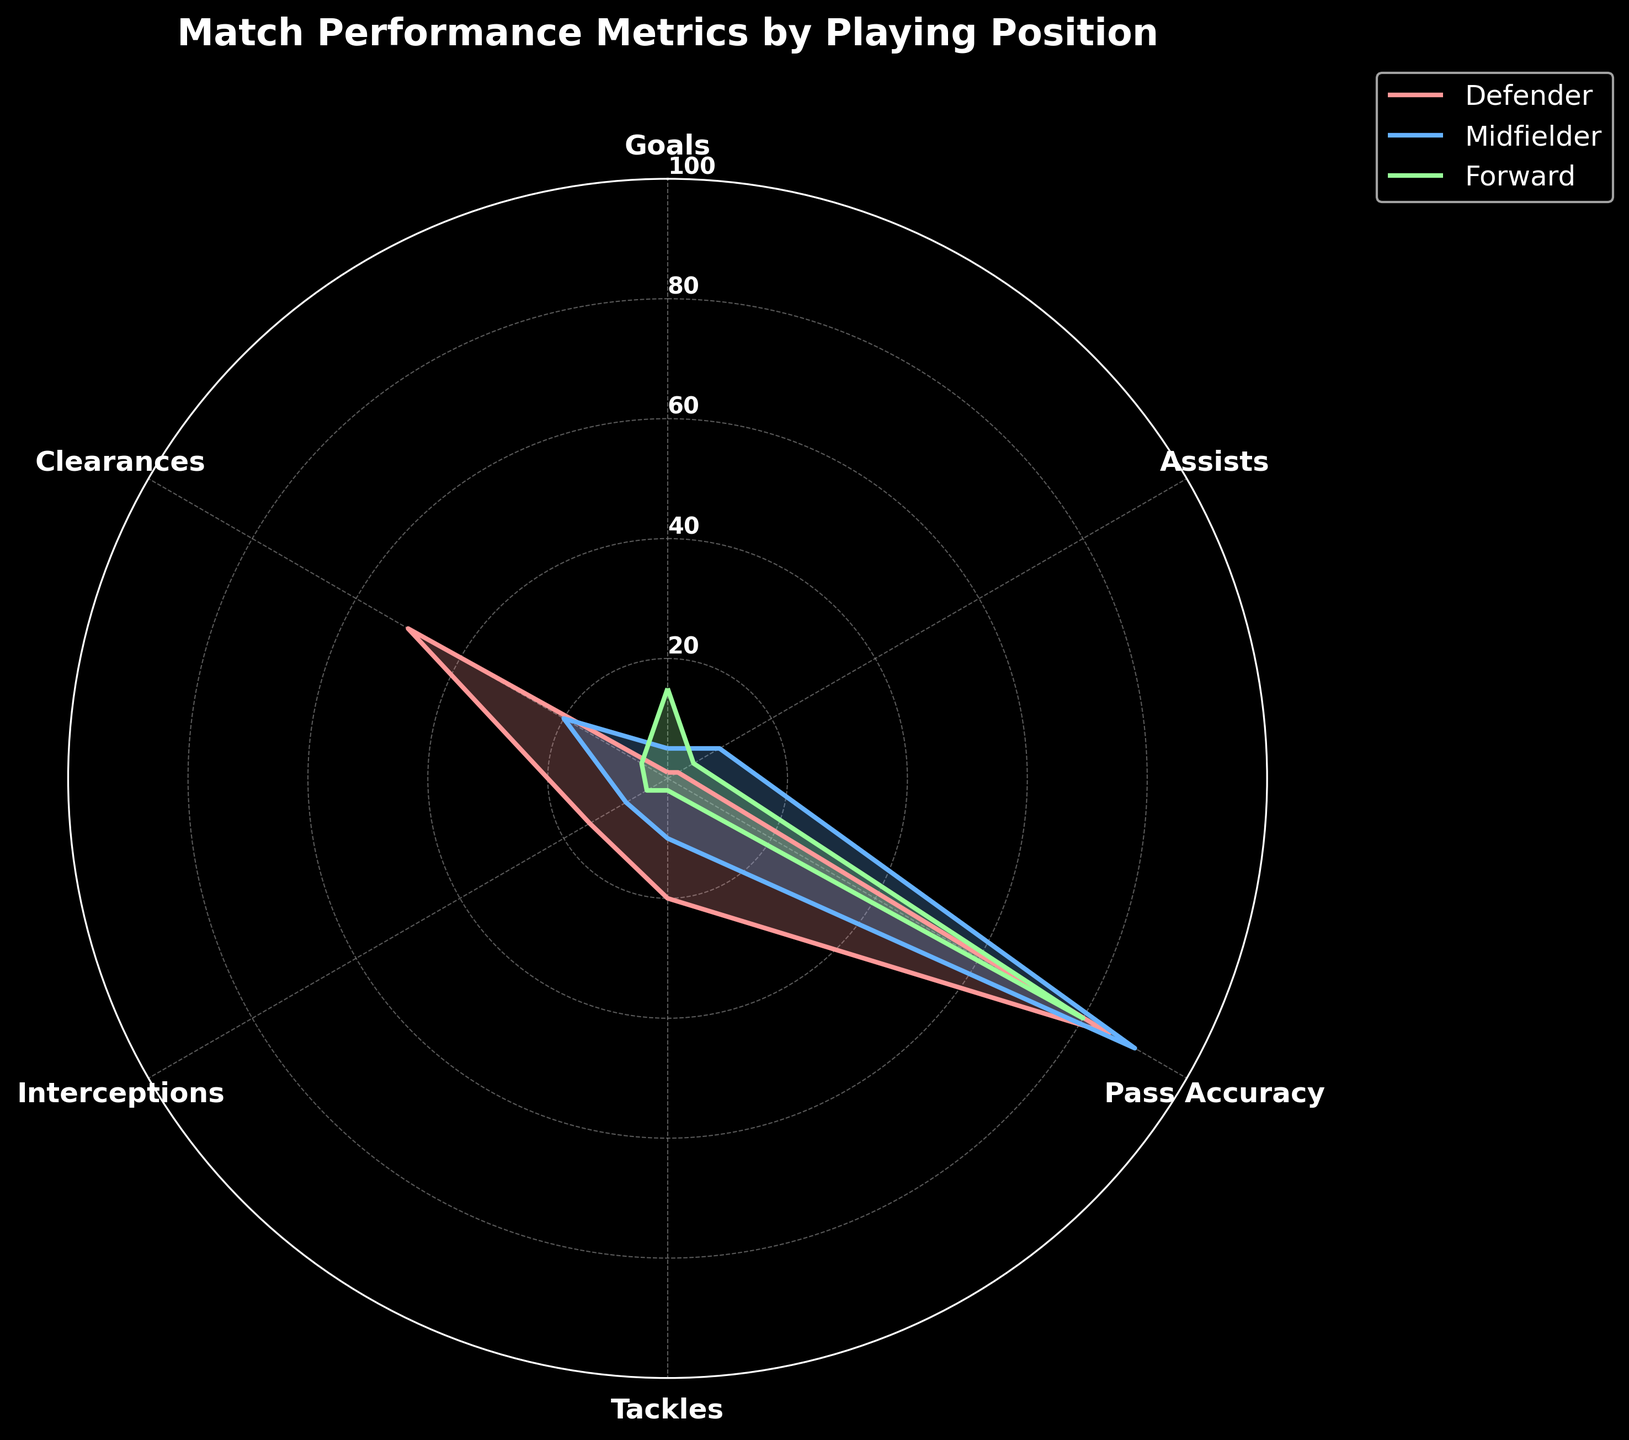What is the title of the radar chart? The title is located at the top of the radar chart. It summarizes the chart's content.
Answer: Match Performance Metrics by Playing Position How many playing positions are shown in the radar chart? The legend or the labels in the radar chart represent the different playing positions. Counting these labels gives the number of groups.
Answer: Three Which position has the highest number of goals? By examining the Goals axis, we can see which group reaches the highest value.
Answer: Forward What is the Pass Accuracy for Midfielders? Look at the Pass Accuracy axis and see where the Midfielder line intersects with it.
Answer: 90 How does the number of Tackles for a Defender compare to that of a Midfielder? Observe the Tackles axis and compare the values. The Defender’s value is marked at a higher level than that of the Midfielder.
Answer: Defender has more What is the combined total of Clearances for all positions? Add the Clearances values for Defender, Midfielder, and Forward: 50 (Defender) + 20 (Midfielder) + 5 (Forward) = 75
Answer: 75 Which position shows the lowest Pass Accuracy? Look at the Pass Accuracy axis and identify the lowest intersecting point among the positions.
Answer: Forward Does any position have a value of 10 in any metric? If yes, which metric and position? Check each metric axis for a value of 10, then identify the intersecting line and position.
Answer: Yes, Tackles and Midfielder What is the average number of Assists across all positions? Add the Assists values for Defender, Midfielder, and Forward, then divide by the number of positions: (2 + 10 + 5) / 3 = 5.67
Answer: 5.67 Among the three positions, which has the highest number of Interceptions? Observe the Interceptions axis and identify the highest intersecting point.
Answer: Defender 